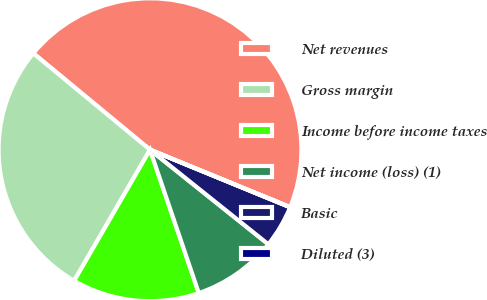Convert chart. <chart><loc_0><loc_0><loc_500><loc_500><pie_chart><fcel>Net revenues<fcel>Gross margin<fcel>Income before income taxes<fcel>Net income (loss) (1)<fcel>Basic<fcel>Diluted (3)<nl><fcel>45.2%<fcel>27.64%<fcel>13.57%<fcel>9.05%<fcel>4.53%<fcel>0.01%<nl></chart> 